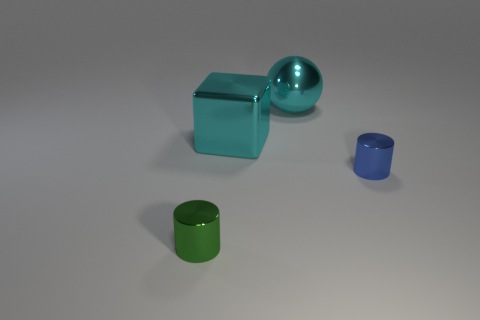There is a small cylinder right of the tiny metallic cylinder that is on the left side of the small blue cylinder; how many tiny green shiny things are right of it?
Your answer should be very brief. 0. Is the shape of the green metal thing the same as the tiny thing behind the green shiny cylinder?
Offer a terse response. Yes. What is the color of the thing that is both on the right side of the big metallic cube and in front of the cyan cube?
Your answer should be very brief. Blue. There is a cylinder that is to the left of the tiny cylinder behind the object that is left of the large block; what is it made of?
Your answer should be very brief. Metal. What is the material of the big block?
Your answer should be very brief. Metal. There is a green object that is the same shape as the blue shiny object; what is its size?
Make the answer very short. Small. Do the block and the ball have the same color?
Offer a terse response. Yes. Is the number of small green things to the right of the green metal thing the same as the number of cyan shiny blocks?
Your answer should be compact. No. There is a cylinder on the left side of the sphere; is its size the same as the small blue shiny cylinder?
Provide a short and direct response. Yes. What number of cylinders are behind the green metal cylinder?
Provide a short and direct response. 1. 